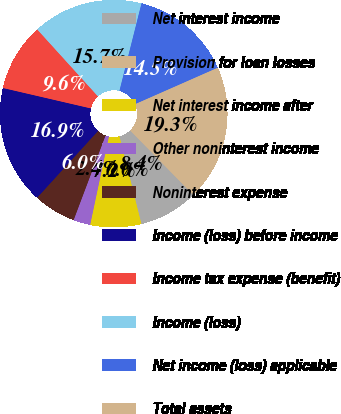Convert chart. <chart><loc_0><loc_0><loc_500><loc_500><pie_chart><fcel>Net interest income<fcel>Provision for loan losses<fcel>Net interest income after<fcel>Other noninterest income<fcel>Noninterest expense<fcel>Income (loss) before income<fcel>Income tax expense (benefit)<fcel>Income (loss)<fcel>Net income (loss) applicable<fcel>Total assets<nl><fcel>8.43%<fcel>0.01%<fcel>7.23%<fcel>2.41%<fcel>6.03%<fcel>16.86%<fcel>9.64%<fcel>15.66%<fcel>14.46%<fcel>19.27%<nl></chart> 